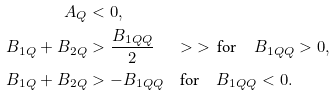Convert formula to latex. <formula><loc_0><loc_0><loc_500><loc_500>A _ { Q } & < 0 , \\ B _ { 1 Q } + B _ { 2 Q } & > \frac { B _ { 1 Q Q } } { 2 } \quad \ > \ > \, \text {for} \quad B _ { 1 Q Q } > 0 , \\ B _ { 1 Q } + B _ { 2 Q } & > - B _ { 1 Q Q } \quad \text {for} \quad B _ { 1 Q Q } < 0 .</formula> 